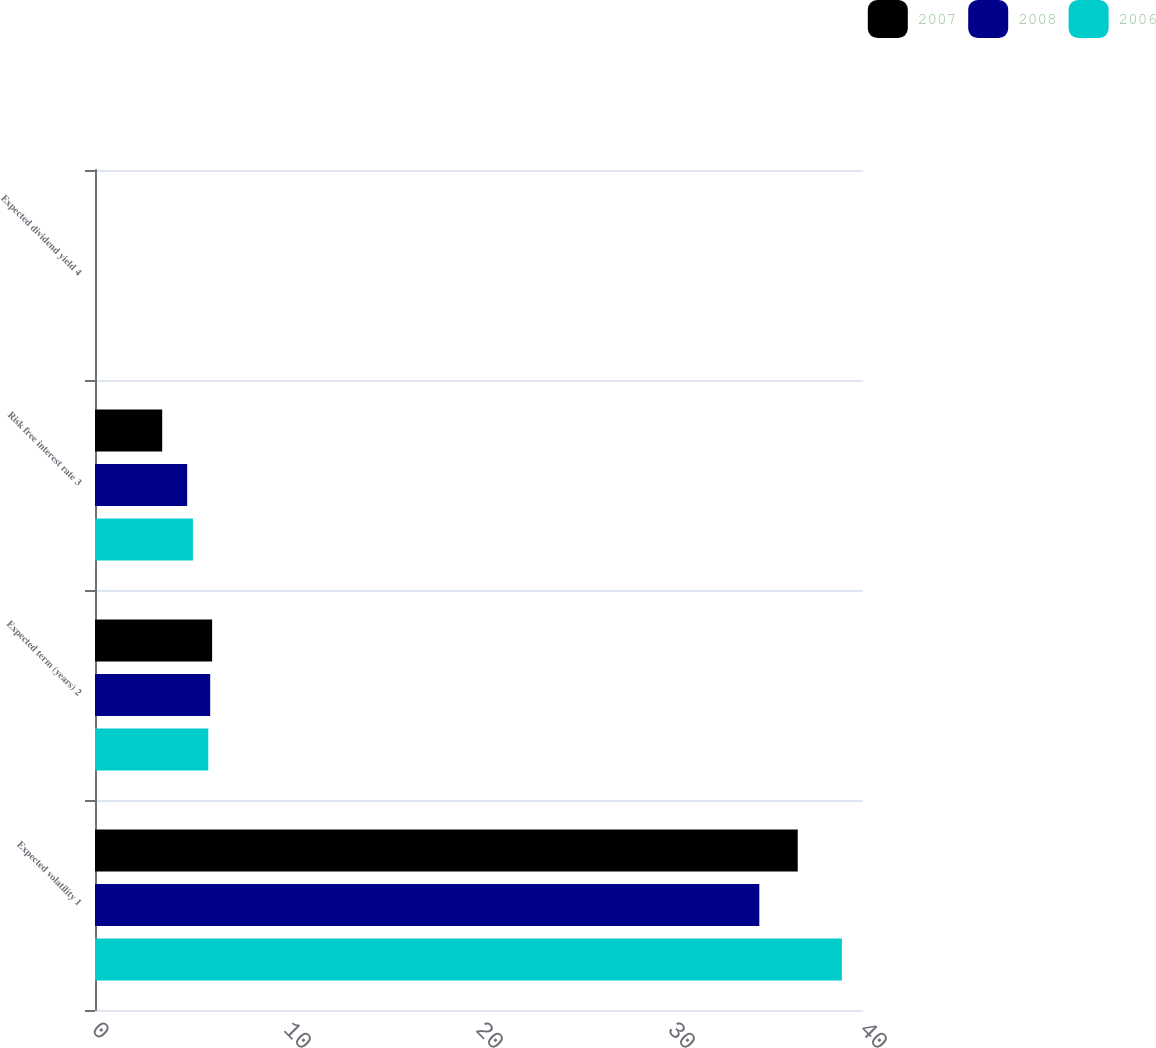Convert chart to OTSL. <chart><loc_0><loc_0><loc_500><loc_500><stacked_bar_chart><ecel><fcel>Expected volatility 1<fcel>Expected term (years) 2<fcel>Risk free interest rate 3<fcel>Expected dividend yield 4<nl><fcel>2007<fcel>36.6<fcel>6.1<fcel>3.5<fcel>0<nl><fcel>2008<fcel>34.6<fcel>6<fcel>4.8<fcel>0<nl><fcel>2006<fcel>38.9<fcel>5.9<fcel>5.1<fcel>0<nl></chart> 